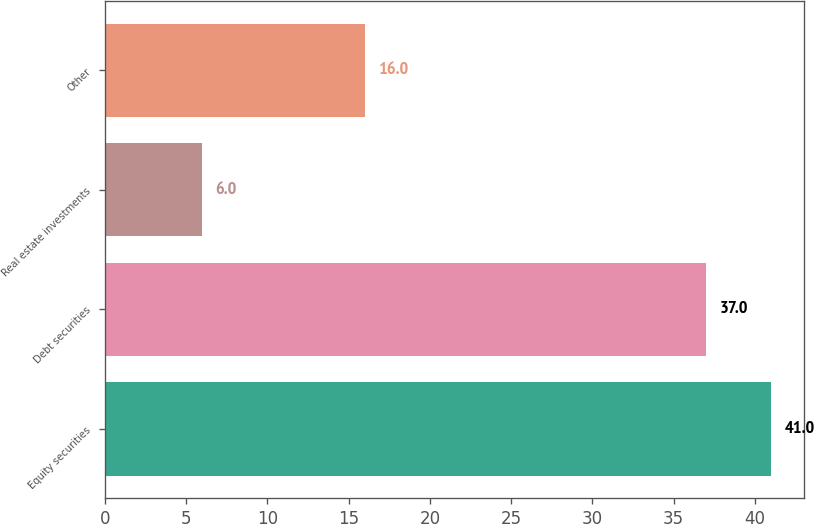Convert chart to OTSL. <chart><loc_0><loc_0><loc_500><loc_500><bar_chart><fcel>Equity securities<fcel>Debt securities<fcel>Real estate investments<fcel>Other<nl><fcel>41<fcel>37<fcel>6<fcel>16<nl></chart> 